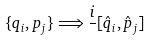<formula> <loc_0><loc_0><loc_500><loc_500>\{ q _ { i } , p _ { j } \} \Longrightarrow { \frac { i } { } } [ { \hat { q } } _ { i } , { \hat { p } } _ { j } ]</formula> 